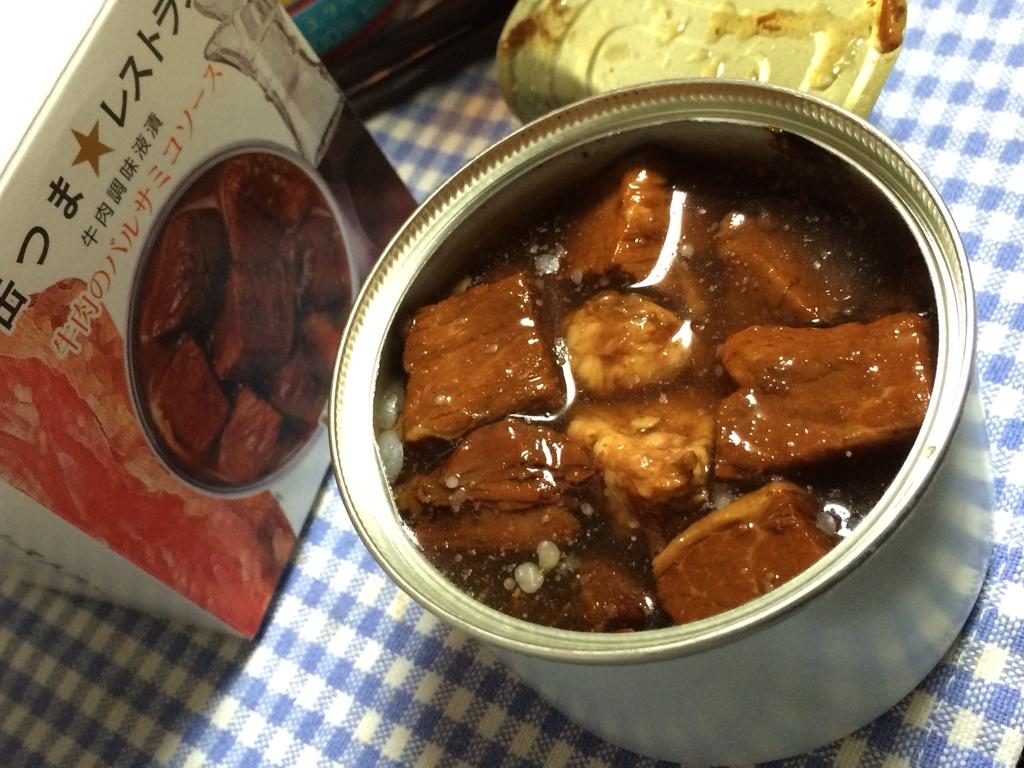What is the primary substance visible in the image? There is liquid in the image. What type of food items can be seen in the image? There are food items in a small container. What type of container is present in the image? There is a box in the image. What else can be seen in the image besides the liquid, food items, and box? There are other objects in the image. What type of material is present in the image? There is a cloth in the image. What holiday is being celebrated in the image? There is no indication of a holiday being celebrated in the image. What type of teaching is taking place in the image? There is no teaching activity depicted in the image. 